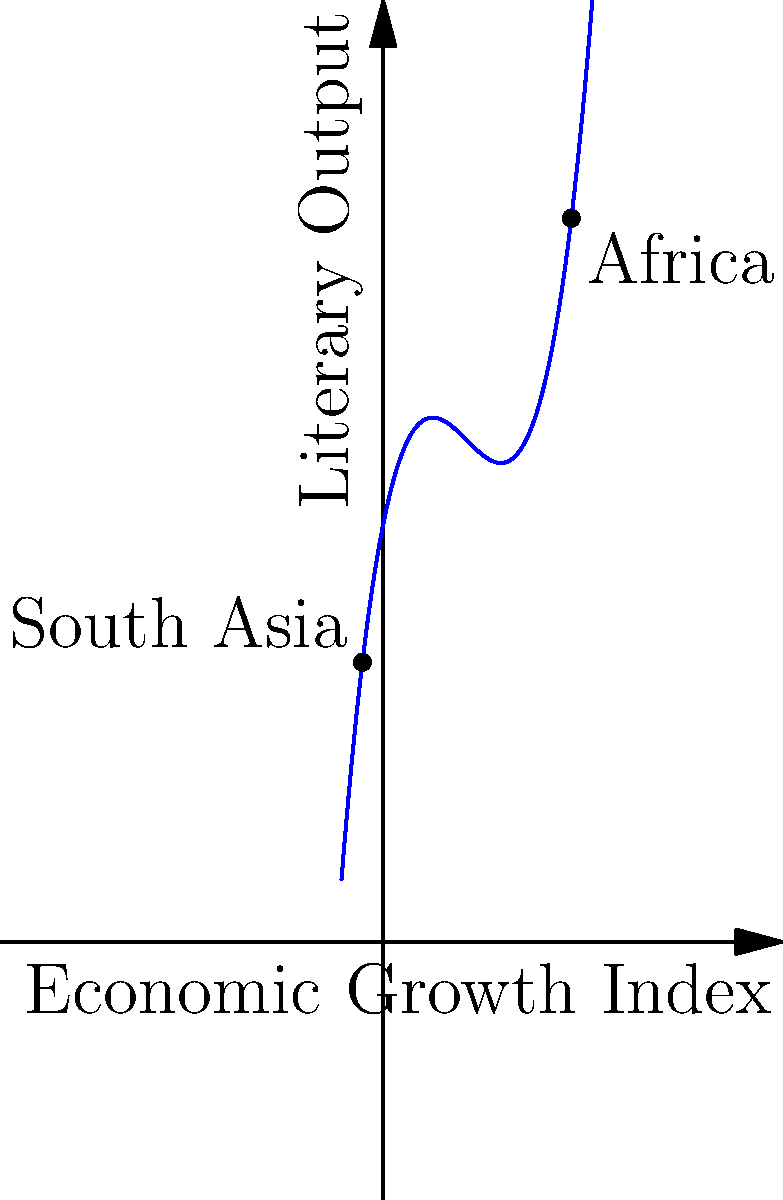The graph represents a polynomial regression model of the relationship between economic growth and literary output in postcolonial South Asian and African countries. Given that the function is of the form $f(x) = ax^3 + bx^2 + cx + d$, where $x$ represents the Economic Growth Index and $f(x)$ represents the Literary Output, determine the values of $a$, $b$, $c$, and $d$. Additionally, at what Economic Growth Index does the Literary Output reach its minimum value? To solve this problem, we'll follow these steps:

1) From the given information, we know the function is of the form:
   $f(x) = ax^3 + bx^2 + cx + d$

2) By observing the graph, we can see that:
   a) The coefficient of $x^3$ (a) is positive (curve goes up as x increases)
   b) The curve has a local minimum and maximum

3) The exact function is given as $f(x) = 0.5x^3 - 3x^2 + 5x + 10$

4) Therefore, $a = 0.5$, $b = -3$, $c = 5$, and $d = 10$

5) To find the minimum point, we need to find where the derivative equals zero:
   $f'(x) = 1.5x^2 - 6x + 5$
   
6) Set $f'(x) = 0$:
   $1.5x^2 - 6x + 5 = 0$

7) Solve this quadratic equation:
   $x = \frac{6 \pm \sqrt{36 - 30}}{3} = \frac{6 \pm \sqrt{6}}{3}$

8) The smaller value of x will give us the minimum point:
   $x = \frac{6 - \sqrt{6}}{3} \approx 1.18$

Therefore, the Literary Output reaches its minimum value when the Economic Growth Index is approximately 1.18.
Answer: $a=0.5$, $b=-3$, $c=5$, $d=10$; Minimum at $x \approx 1.18$ 